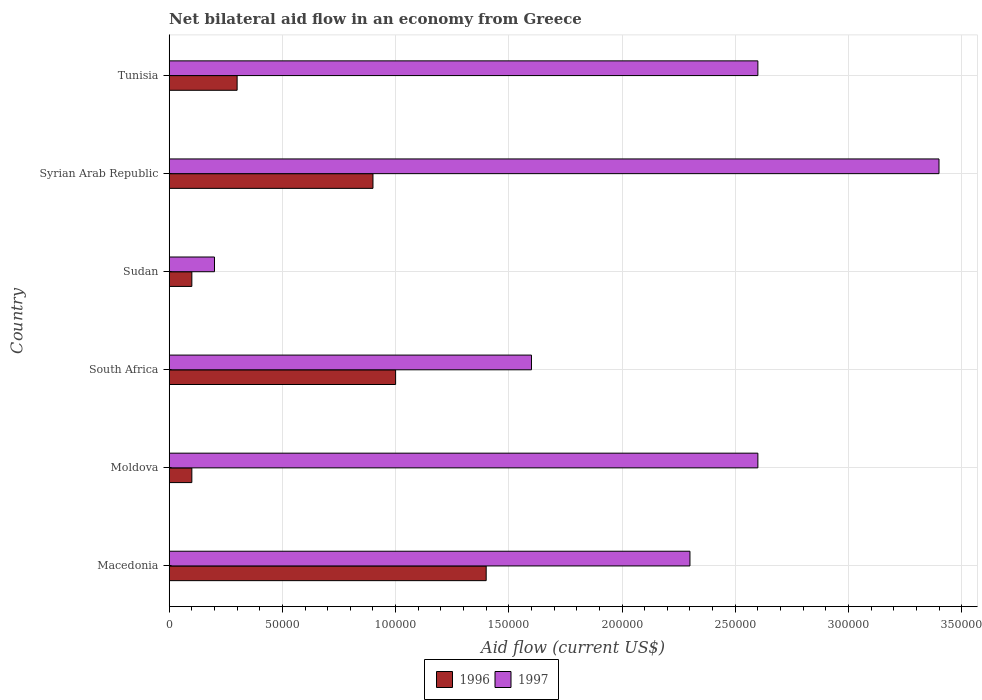How many bars are there on the 1st tick from the top?
Your response must be concise. 2. How many bars are there on the 3rd tick from the bottom?
Provide a short and direct response. 2. What is the label of the 2nd group of bars from the top?
Make the answer very short. Syrian Arab Republic. In which country was the net bilateral aid flow in 1997 maximum?
Give a very brief answer. Syrian Arab Republic. In which country was the net bilateral aid flow in 1997 minimum?
Provide a short and direct response. Sudan. What is the total net bilateral aid flow in 1997 in the graph?
Your answer should be compact. 1.27e+06. What is the difference between the net bilateral aid flow in 1997 in Moldova and the net bilateral aid flow in 1996 in Sudan?
Offer a terse response. 2.50e+05. What is the average net bilateral aid flow in 1996 per country?
Your response must be concise. 6.33e+04. What is the difference between the net bilateral aid flow in 1997 and net bilateral aid flow in 1996 in Sudan?
Your answer should be compact. 10000. What is the ratio of the net bilateral aid flow in 1996 in South Africa to that in Tunisia?
Your answer should be very brief. 3.33. Is the difference between the net bilateral aid flow in 1997 in Sudan and Tunisia greater than the difference between the net bilateral aid flow in 1996 in Sudan and Tunisia?
Give a very brief answer. No. In how many countries, is the net bilateral aid flow in 1996 greater than the average net bilateral aid flow in 1996 taken over all countries?
Your answer should be compact. 3. Is the sum of the net bilateral aid flow in 1996 in South Africa and Sudan greater than the maximum net bilateral aid flow in 1997 across all countries?
Your response must be concise. No. How many bars are there?
Provide a short and direct response. 12. Are all the bars in the graph horizontal?
Your answer should be compact. Yes. Are the values on the major ticks of X-axis written in scientific E-notation?
Provide a succinct answer. No. How are the legend labels stacked?
Make the answer very short. Horizontal. What is the title of the graph?
Make the answer very short. Net bilateral aid flow in an economy from Greece. Does "1966" appear as one of the legend labels in the graph?
Provide a short and direct response. No. What is the label or title of the X-axis?
Provide a short and direct response. Aid flow (current US$). What is the Aid flow (current US$) in 1996 in Macedonia?
Make the answer very short. 1.40e+05. What is the Aid flow (current US$) of 1996 in Moldova?
Your answer should be compact. 10000. What is the Aid flow (current US$) of 1997 in South Africa?
Your response must be concise. 1.60e+05. What is the Aid flow (current US$) of 1996 in Sudan?
Offer a terse response. 10000. What is the Aid flow (current US$) of 1996 in Syrian Arab Republic?
Your answer should be very brief. 9.00e+04. What is the Aid flow (current US$) in 1997 in Tunisia?
Provide a succinct answer. 2.60e+05. Across all countries, what is the maximum Aid flow (current US$) of 1997?
Ensure brevity in your answer.  3.40e+05. What is the total Aid flow (current US$) in 1997 in the graph?
Give a very brief answer. 1.27e+06. What is the difference between the Aid flow (current US$) in 1996 in Macedonia and that in South Africa?
Make the answer very short. 4.00e+04. What is the difference between the Aid flow (current US$) in 1996 in Macedonia and that in Sudan?
Offer a terse response. 1.30e+05. What is the difference between the Aid flow (current US$) in 1997 in Macedonia and that in Sudan?
Your answer should be very brief. 2.10e+05. What is the difference between the Aid flow (current US$) in 1997 in Macedonia and that in Syrian Arab Republic?
Offer a terse response. -1.10e+05. What is the difference between the Aid flow (current US$) of 1997 in Macedonia and that in Tunisia?
Provide a succinct answer. -3.00e+04. What is the difference between the Aid flow (current US$) in 1997 in Moldova and that in Sudan?
Provide a succinct answer. 2.40e+05. What is the difference between the Aid flow (current US$) of 1996 in Moldova and that in Tunisia?
Your answer should be very brief. -2.00e+04. What is the difference between the Aid flow (current US$) in 1996 in South Africa and that in Sudan?
Provide a succinct answer. 9.00e+04. What is the difference between the Aid flow (current US$) in 1997 in South Africa and that in Sudan?
Offer a terse response. 1.40e+05. What is the difference between the Aid flow (current US$) of 1996 in South Africa and that in Syrian Arab Republic?
Provide a succinct answer. 10000. What is the difference between the Aid flow (current US$) of 1997 in South Africa and that in Syrian Arab Republic?
Offer a terse response. -1.80e+05. What is the difference between the Aid flow (current US$) of 1996 in South Africa and that in Tunisia?
Your answer should be very brief. 7.00e+04. What is the difference between the Aid flow (current US$) of 1997 in South Africa and that in Tunisia?
Offer a terse response. -1.00e+05. What is the difference between the Aid flow (current US$) of 1997 in Sudan and that in Syrian Arab Republic?
Provide a succinct answer. -3.20e+05. What is the difference between the Aid flow (current US$) in 1997 in Sudan and that in Tunisia?
Make the answer very short. -2.40e+05. What is the difference between the Aid flow (current US$) of 1997 in Syrian Arab Republic and that in Tunisia?
Make the answer very short. 8.00e+04. What is the difference between the Aid flow (current US$) in 1996 in Macedonia and the Aid flow (current US$) in 1997 in South Africa?
Keep it short and to the point. -2.00e+04. What is the difference between the Aid flow (current US$) in 1996 in Macedonia and the Aid flow (current US$) in 1997 in Syrian Arab Republic?
Make the answer very short. -2.00e+05. What is the difference between the Aid flow (current US$) of 1996 in Macedonia and the Aid flow (current US$) of 1997 in Tunisia?
Give a very brief answer. -1.20e+05. What is the difference between the Aid flow (current US$) of 1996 in Moldova and the Aid flow (current US$) of 1997 in Sudan?
Your response must be concise. -10000. What is the difference between the Aid flow (current US$) of 1996 in Moldova and the Aid flow (current US$) of 1997 in Syrian Arab Republic?
Your answer should be very brief. -3.30e+05. What is the difference between the Aid flow (current US$) of 1996 in South Africa and the Aid flow (current US$) of 1997 in Sudan?
Your answer should be very brief. 8.00e+04. What is the difference between the Aid flow (current US$) in 1996 in South Africa and the Aid flow (current US$) in 1997 in Tunisia?
Give a very brief answer. -1.60e+05. What is the difference between the Aid flow (current US$) in 1996 in Sudan and the Aid flow (current US$) in 1997 in Syrian Arab Republic?
Offer a terse response. -3.30e+05. What is the difference between the Aid flow (current US$) of 1996 in Syrian Arab Republic and the Aid flow (current US$) of 1997 in Tunisia?
Give a very brief answer. -1.70e+05. What is the average Aid flow (current US$) of 1996 per country?
Your answer should be compact. 6.33e+04. What is the average Aid flow (current US$) of 1997 per country?
Offer a terse response. 2.12e+05. What is the difference between the Aid flow (current US$) of 1996 and Aid flow (current US$) of 1997 in South Africa?
Ensure brevity in your answer.  -6.00e+04. What is the difference between the Aid flow (current US$) in 1996 and Aid flow (current US$) in 1997 in Tunisia?
Make the answer very short. -2.30e+05. What is the ratio of the Aid flow (current US$) in 1996 in Macedonia to that in Moldova?
Offer a very short reply. 14. What is the ratio of the Aid flow (current US$) in 1997 in Macedonia to that in Moldova?
Your answer should be compact. 0.88. What is the ratio of the Aid flow (current US$) of 1996 in Macedonia to that in South Africa?
Your answer should be very brief. 1.4. What is the ratio of the Aid flow (current US$) in 1997 in Macedonia to that in South Africa?
Ensure brevity in your answer.  1.44. What is the ratio of the Aid flow (current US$) of 1996 in Macedonia to that in Sudan?
Keep it short and to the point. 14. What is the ratio of the Aid flow (current US$) of 1997 in Macedonia to that in Sudan?
Your answer should be very brief. 11.5. What is the ratio of the Aid flow (current US$) of 1996 in Macedonia to that in Syrian Arab Republic?
Provide a short and direct response. 1.56. What is the ratio of the Aid flow (current US$) in 1997 in Macedonia to that in Syrian Arab Republic?
Your answer should be very brief. 0.68. What is the ratio of the Aid flow (current US$) of 1996 in Macedonia to that in Tunisia?
Ensure brevity in your answer.  4.67. What is the ratio of the Aid flow (current US$) of 1997 in Macedonia to that in Tunisia?
Your response must be concise. 0.88. What is the ratio of the Aid flow (current US$) in 1997 in Moldova to that in South Africa?
Offer a very short reply. 1.62. What is the ratio of the Aid flow (current US$) in 1996 in Moldova to that in Sudan?
Your answer should be compact. 1. What is the ratio of the Aid flow (current US$) in 1997 in Moldova to that in Syrian Arab Republic?
Offer a terse response. 0.76. What is the ratio of the Aid flow (current US$) in 1996 in Moldova to that in Tunisia?
Offer a terse response. 0.33. What is the ratio of the Aid flow (current US$) of 1997 in Moldova to that in Tunisia?
Ensure brevity in your answer.  1. What is the ratio of the Aid flow (current US$) of 1997 in South Africa to that in Sudan?
Your response must be concise. 8. What is the ratio of the Aid flow (current US$) of 1997 in South Africa to that in Syrian Arab Republic?
Make the answer very short. 0.47. What is the ratio of the Aid flow (current US$) of 1996 in South Africa to that in Tunisia?
Offer a terse response. 3.33. What is the ratio of the Aid flow (current US$) of 1997 in South Africa to that in Tunisia?
Give a very brief answer. 0.62. What is the ratio of the Aid flow (current US$) of 1996 in Sudan to that in Syrian Arab Republic?
Your answer should be compact. 0.11. What is the ratio of the Aid flow (current US$) of 1997 in Sudan to that in Syrian Arab Republic?
Your answer should be compact. 0.06. What is the ratio of the Aid flow (current US$) of 1996 in Sudan to that in Tunisia?
Your response must be concise. 0.33. What is the ratio of the Aid flow (current US$) of 1997 in Sudan to that in Tunisia?
Keep it short and to the point. 0.08. What is the ratio of the Aid flow (current US$) in 1996 in Syrian Arab Republic to that in Tunisia?
Offer a terse response. 3. What is the ratio of the Aid flow (current US$) in 1997 in Syrian Arab Republic to that in Tunisia?
Give a very brief answer. 1.31. What is the difference between the highest and the lowest Aid flow (current US$) of 1997?
Offer a terse response. 3.20e+05. 